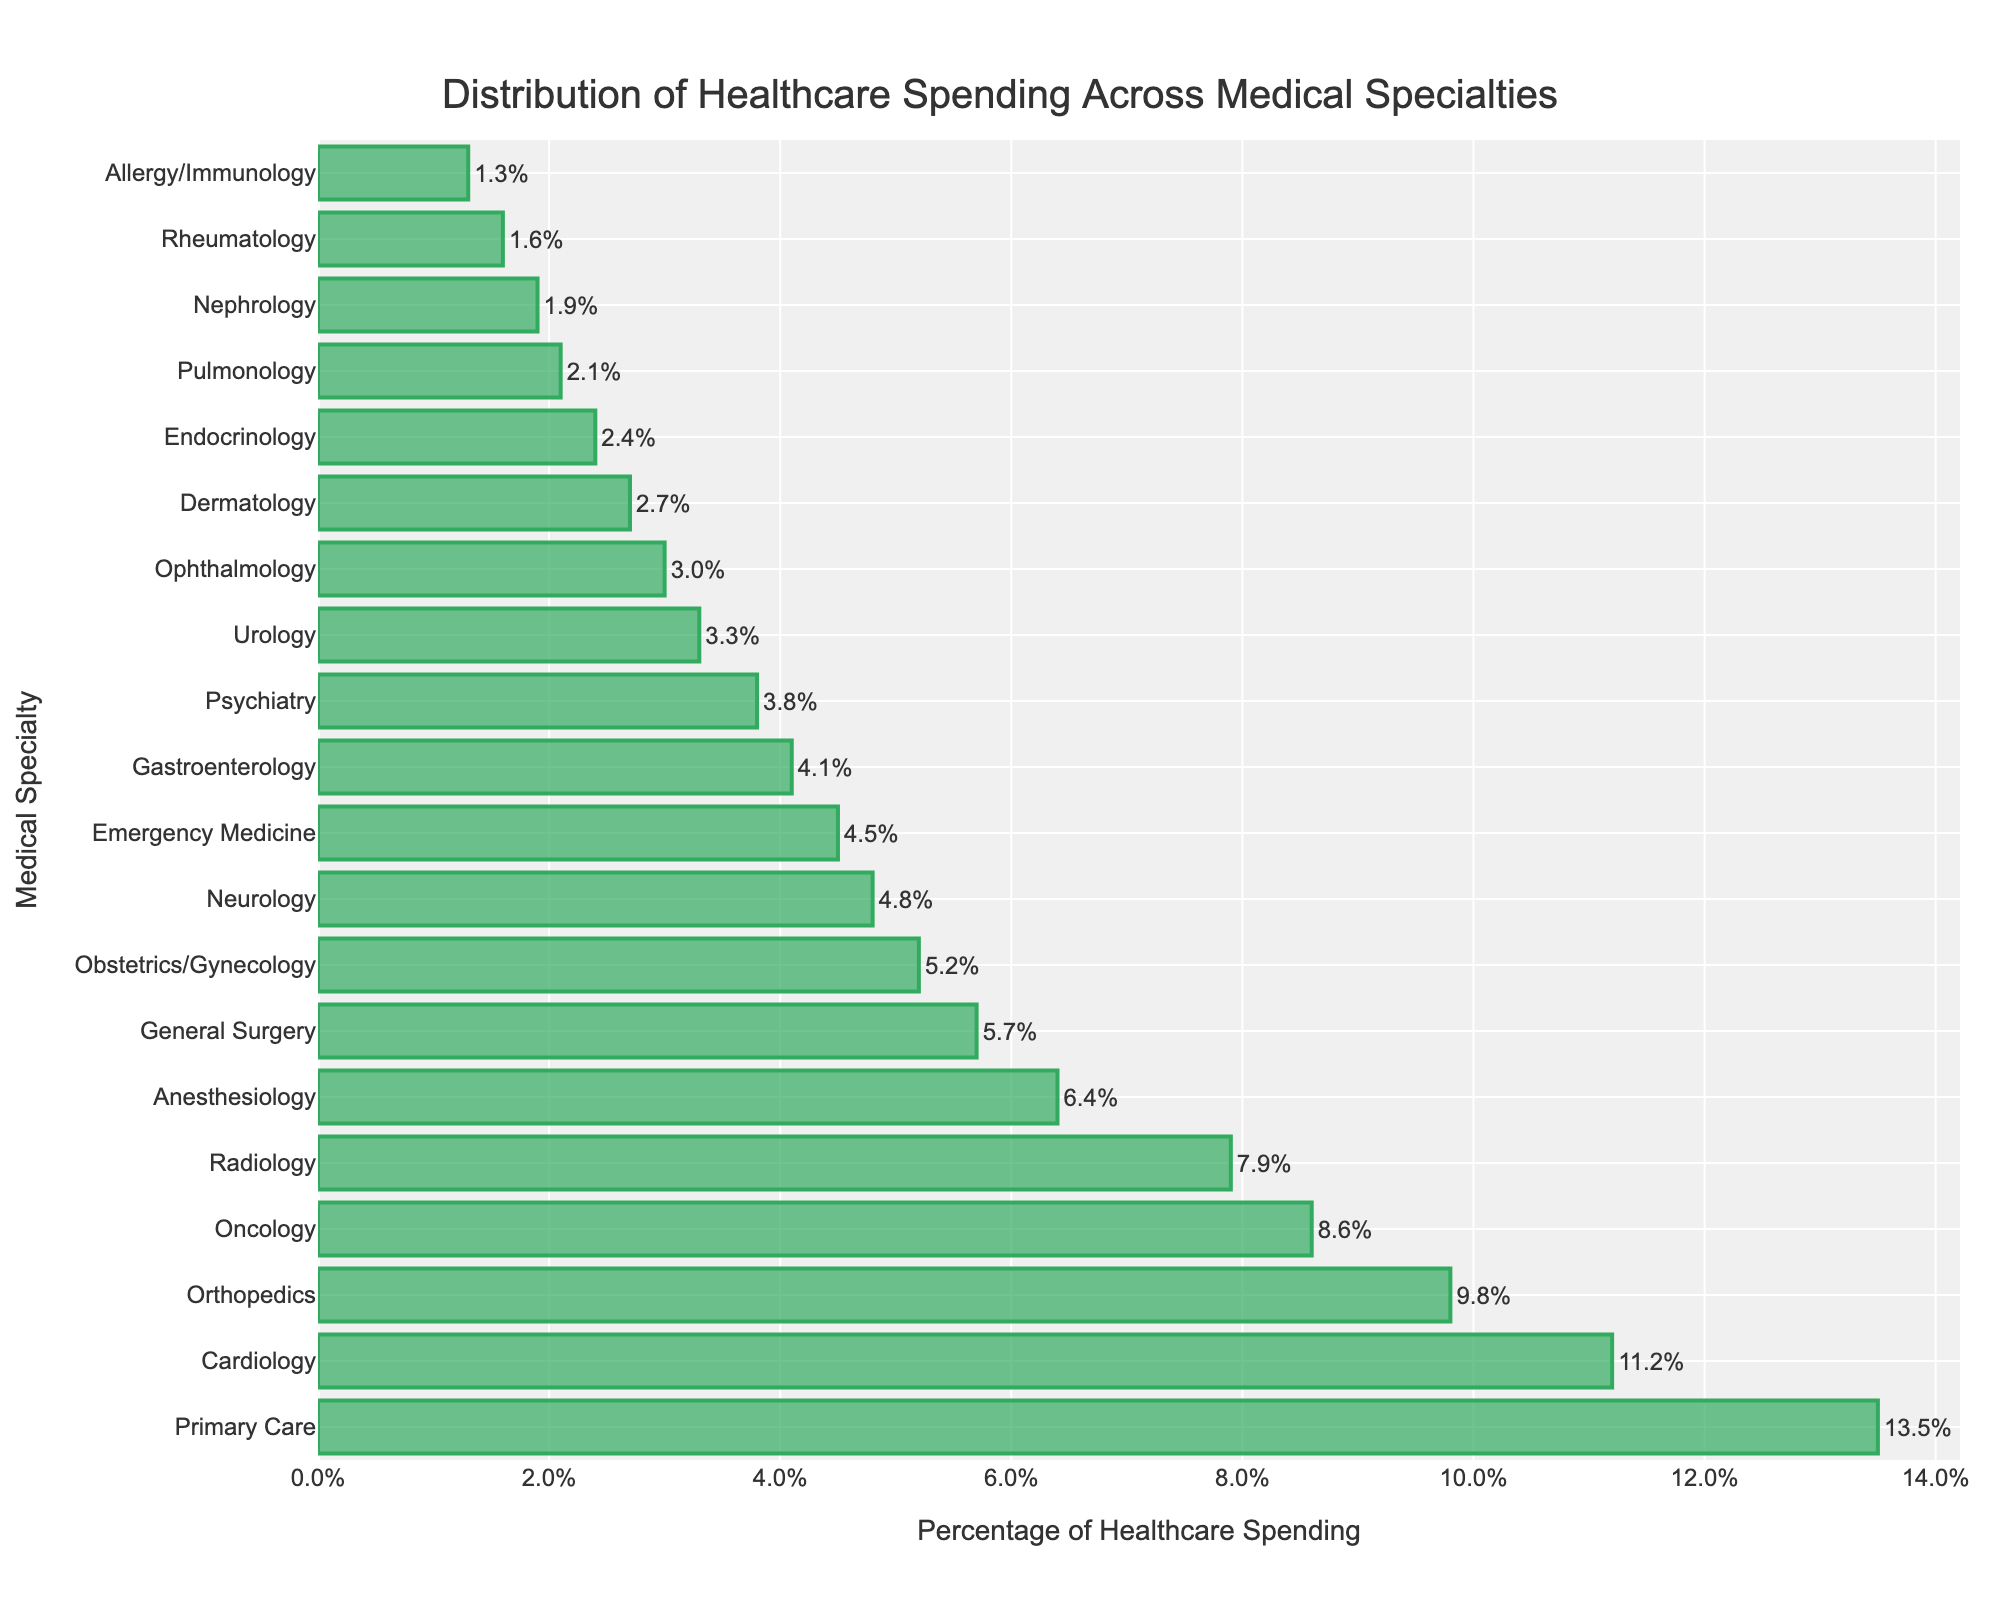Which specialty has the highest percentage of healthcare spending? Look at the bar chart and identify the specialty with the longest bar, which represents the highest percentage of healthcare spending.
Answer: Primary Care What are the combined percentages of healthcare spending for Cardiology, Oncology, and Radiology? Add the percentages for Cardiology (11.2%), Oncology (8.6%), and Radiology (7.9%). Therefore, the combined percentage is 11.2 + 8.6 + 7.9.
Answer: 27.7% Which two specialties have the closest spending percentages, and what are these percentages? Compare the percentages for each specialty and find the two that have the smallest difference. Obstetrics/Gynecology (5.2%) and Neurology (4.8%) have a difference of 0.4%.
Answer: Obstetrics/Gynecology: 5.2%, Neurology: 4.8% Is the percentage of spending on Oncology greater than that on Orthopedics? If so, by how much? Refer to the percentages for Oncology (8.6%) and Orthopedics (9.8%). Orthopedics has a higher percentage. Therefore, calculate the difference: 9.8 - 8.6.
Answer: No, Orthopedics is higher by 1.2% What is the total percentage of healthcare spending for the top four specialties? Add the percentages for Primary Care (13.5%), Cardiology (11.2%), Orthopedics (9.8%), and Oncology (8.6%).
Answer: 43.1% What is the difference between the percentage of spending on Anesthesiology and Ophthalmology? Subtract the percentage of Ophthalmology (3.0%) from Anesthesiology (6.4%).
Answer: 3.4% How does the percentage of emergency medicine spending compare to that of dermatology? Compare the percentages of Emergency Medicine (4.5%) and Dermatology (2.7%) to see which is greater. Emergency Medicine has a higher percentage.
Answer: Emergency Medicine is higher Which specialties have spending percentages below 3%, and what are their values? Identify all bars that represent less than 3% and list their corresponding specialties and values.
Answer: Urology: 3.3%, Ophthalmology: 3.0%, Dermatology: 2.7%, Endocrinology: 2.4%, Pulmonology: 2.1%, Nephrology: 1.9%, Rheumatology: 1.6%, Allergy/Immunology: 1.3% What is the average percentage of healthcare spending for the bottom five specialties? Identify the bottom five specialties and calculate their average percentage: (Endocrinology 2.4% + Pulmonology 2.1% + Nephrology 1.9% + Rheumatology 1.6% + Allergy/Immunology 1.3%) / 5.
Answer: 1.86% What is the percentage point difference between the highest and the lowest spending specialty? Subtract the percentage of the lowest spending specialty Allergy/Immunology (1.3%) from the highest spending specialty Primary Care (13.5%). 13.5 - 1.3.
Answer: 12.2% 